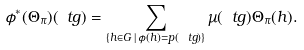<formula> <loc_0><loc_0><loc_500><loc_500>\phi ^ { * } ( \Theta _ { \pi } ) ( \ t g ) = \sum _ { \{ h \in G \, | \, \phi ( h ) = p ( \ t g ) \} } \mu ( \ t g ) \Theta _ { \pi } ( h ) .</formula> 